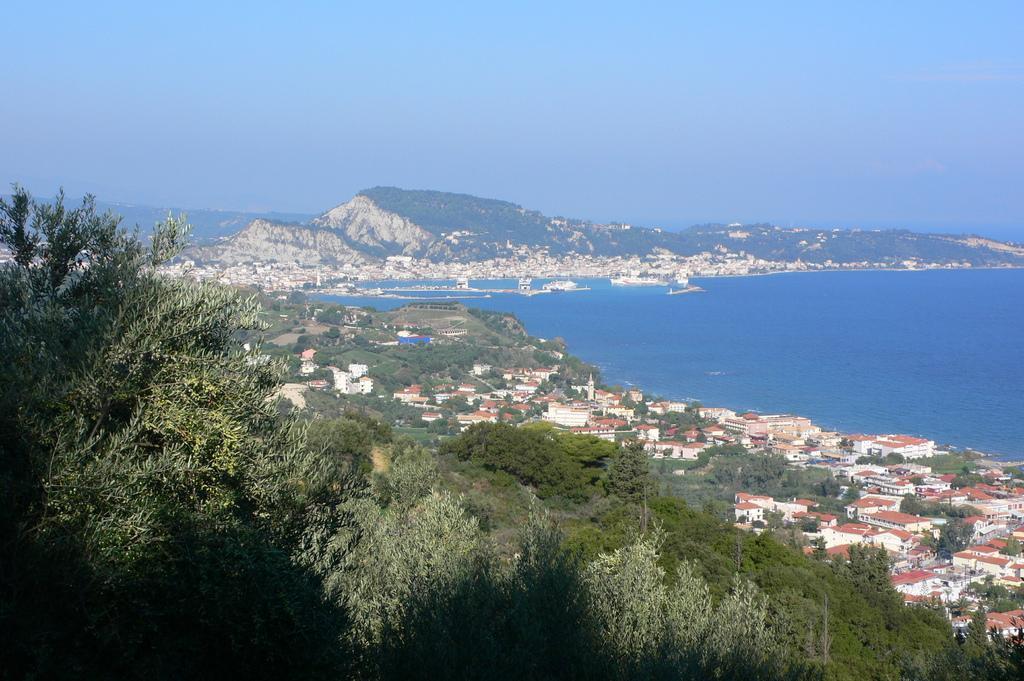Please provide a concise description of this image. In this picture we can observe trees and houses. On the right side there is an ocean. In the background we can observe a hill and a sky. 